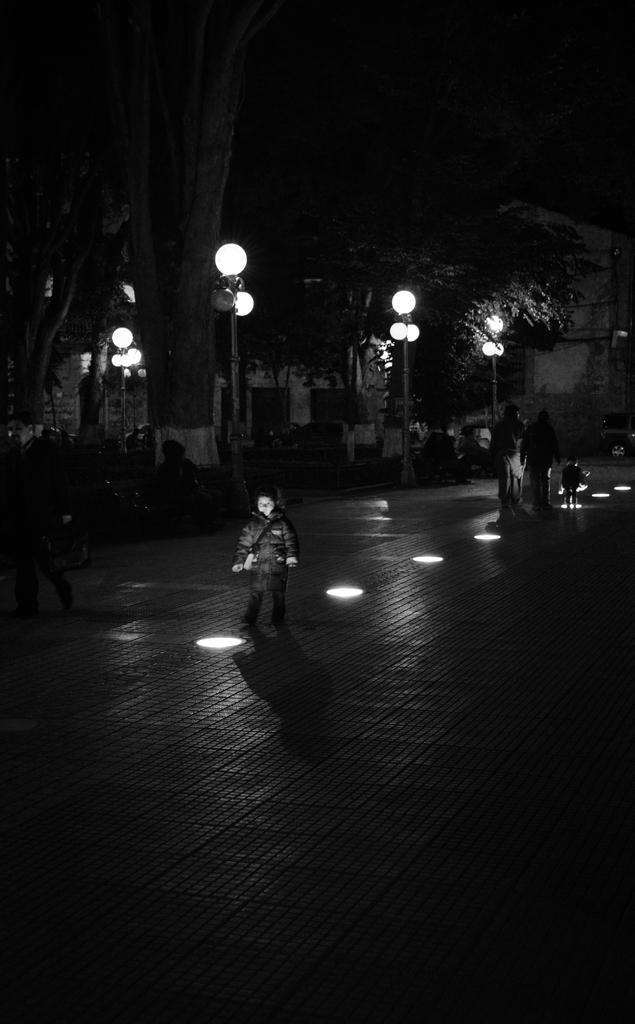Please provide a concise description of this image. In this image there are a group of people who are walking on a road, and in the background there are some buildings, poles, lights and trees. At the bottom there is a road. 